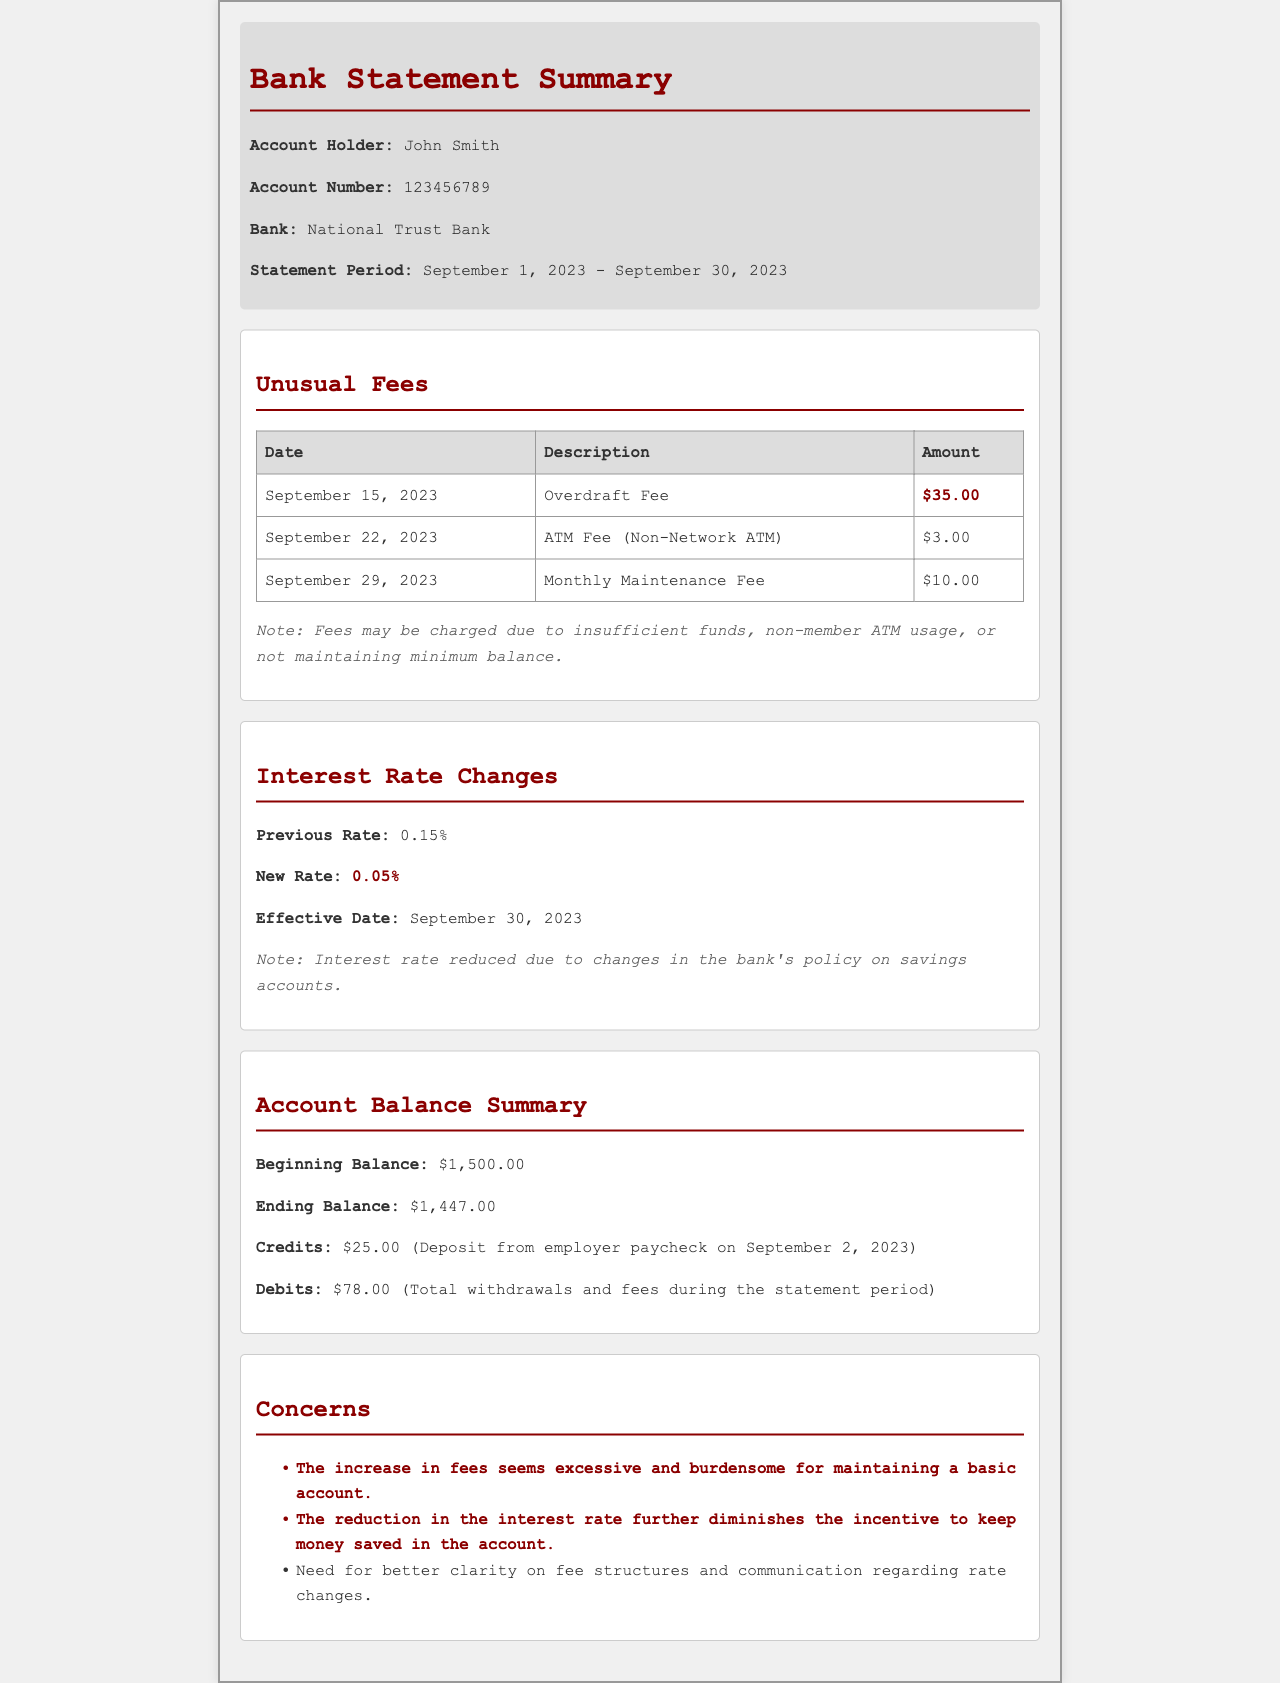what is the account holder's name? The account holder's name is stated at the top of the document under the title "Bank Statement Summary," which indicates John Smith.
Answer: John Smith what is the new interest rate? The new interest rate is provided in the section on interest rate changes, indicating a reduction from the previous rate.
Answer: 0.05% how much was charged for the overdraft fee? The specific amount for the overdraft fee is mentioned in the unusual fees section of the document.
Answer: $35.00 what is the ending balance of the account? The ending balance is found in the account balance summary section, detailing the financial status at the end of the statement period.
Answer: $1,447.00 what date did the interest rate change take effect? The effective date for the new interest rate is clearly stated in the interest rate changes section of the document.
Answer: September 30, 2023 how many total debits were recorded during the statement period? The total debits are summarized in the account balance section, which mentions all withdrawals and fees.
Answer: $78.00 what was the previous interest rate? The previous interest rate is stated in the same section that discusses interest rate changes, reflecting the prior rate before it decreased.
Answer: 0.15% what is one concern mentioned in the document? Concerns listed in the document highlight issues with fees and rate changes. Specific examples are provided, requiring interpretation of the text.
Answer: Excessive fees how often is the monthly maintenance fee charged? While the document shows that there is a monthly maintenance fee, it does not explicitly state the frequency; it can be interpreted as monthly based on typical banking practices.
Answer: Monthly what was the beginning balance of the account? The beginning balance is provided in the account balance summary, indicating the financial starting point for the period in question.
Answer: $1,500.00 